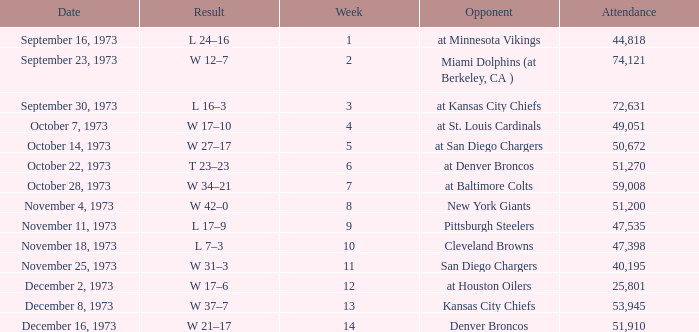What is the attendance for the game against the Kansas City Chiefs earlier than week 13? None. 